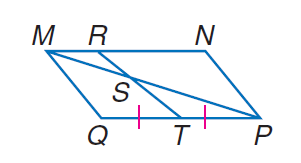Question: Find the ratio of M S to S P, given that M N P Q is a parallelogram with M R = \frac { 1 } { 4 } M N.
Choices:
A. 0.25
B. 0.5
C. 1
D. 2
Answer with the letter. Answer: B 